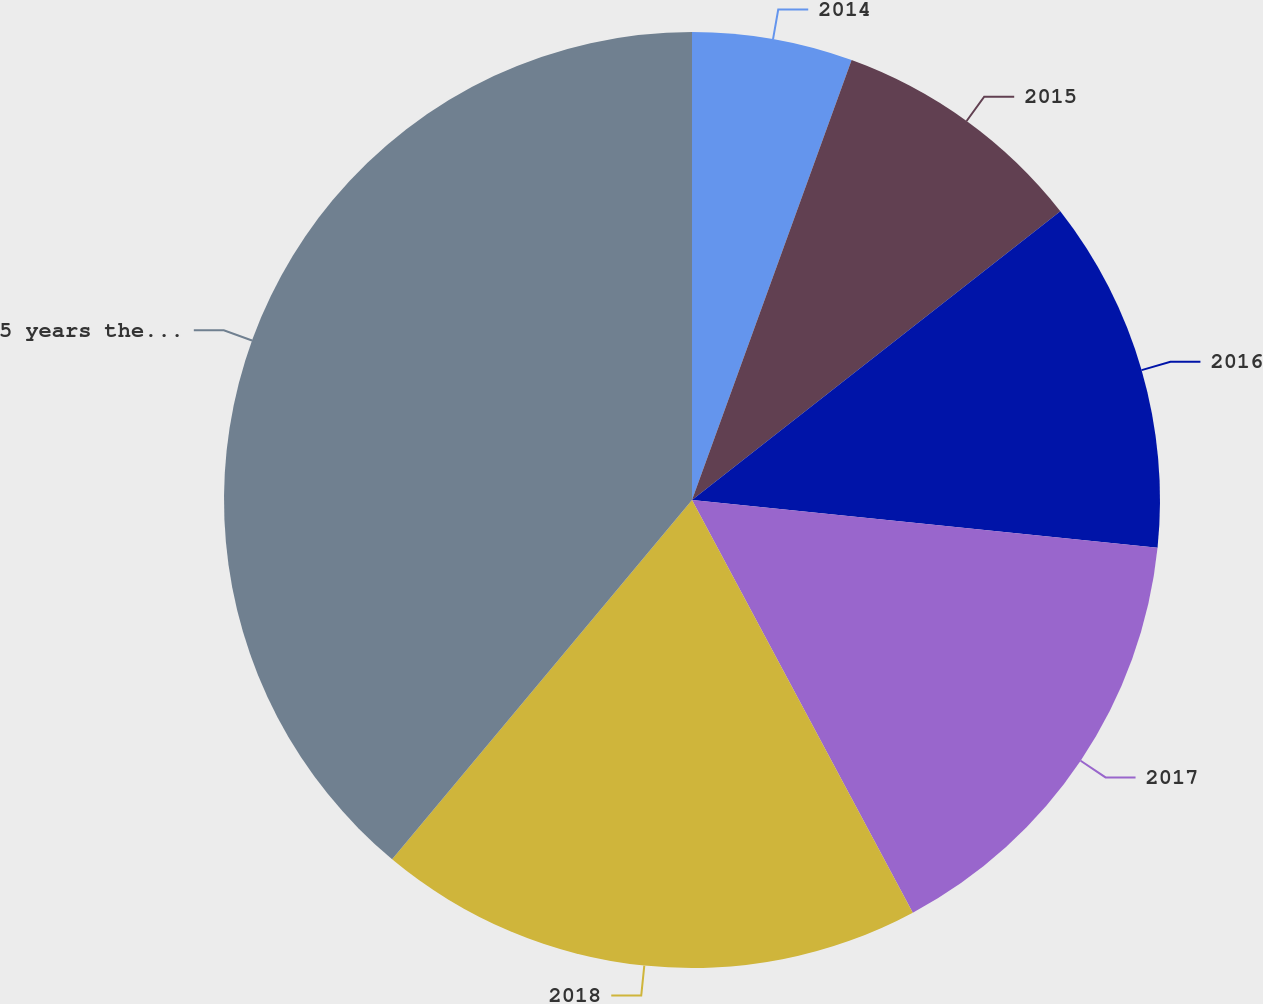<chart> <loc_0><loc_0><loc_500><loc_500><pie_chart><fcel>2014<fcel>2015<fcel>2016<fcel>2017<fcel>2018<fcel>5 years thereafter<nl><fcel>5.54%<fcel>8.88%<fcel>12.21%<fcel>15.55%<fcel>18.89%<fcel>38.93%<nl></chart> 